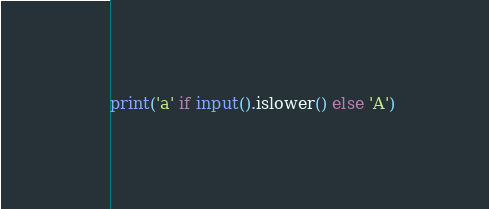Convert code to text. <code><loc_0><loc_0><loc_500><loc_500><_Python_>print('a' if input().islower() else 'A')
</code> 